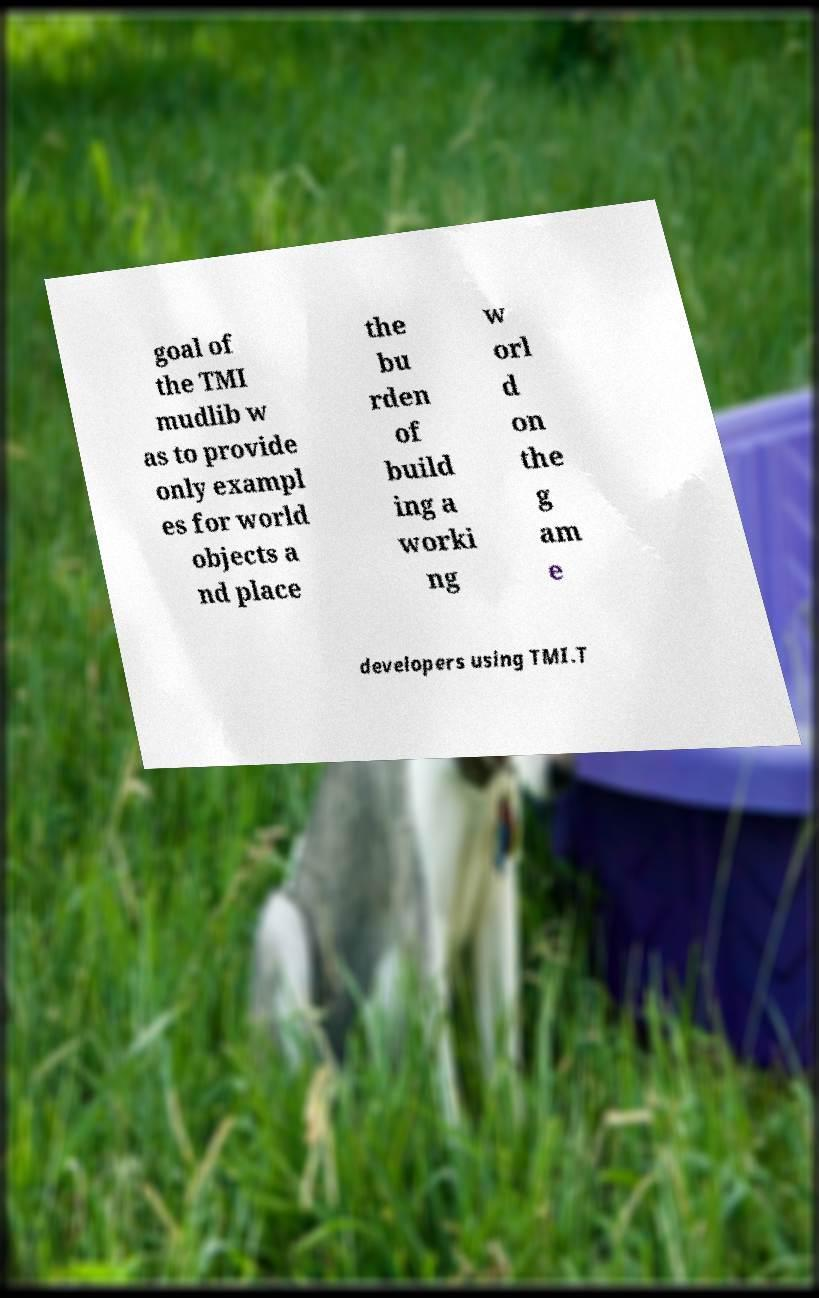There's text embedded in this image that I need extracted. Can you transcribe it verbatim? goal of the TMI mudlib w as to provide only exampl es for world objects a nd place the bu rden of build ing a worki ng w orl d on the g am e developers using TMI.T 